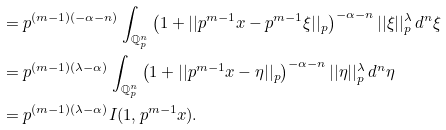<formula> <loc_0><loc_0><loc_500><loc_500>& = p ^ { ( m - 1 ) ( - \alpha - n ) } \int _ { \mathbb { Q } _ { p } ^ { n } } \left ( 1 + | | p ^ { m - 1 } x - p ^ { m - 1 } \xi | | _ { p } \right ) ^ { - \alpha - n } | | \xi | | _ { p } ^ { \lambda } \, d ^ { n } \xi \\ & = p ^ { ( m - 1 ) ( \lambda - \alpha ) } \int _ { \mathbb { Q } _ { p } ^ { n } } \left ( 1 + | | p ^ { m - 1 } x - \eta | | _ { p } \right ) ^ { - \alpha - n } | | \eta | | _ { p } ^ { \lambda } \, d ^ { n } \eta \\ & = p ^ { ( m - 1 ) ( \lambda - \alpha ) } I ( 1 , p ^ { m - 1 } x ) .</formula> 